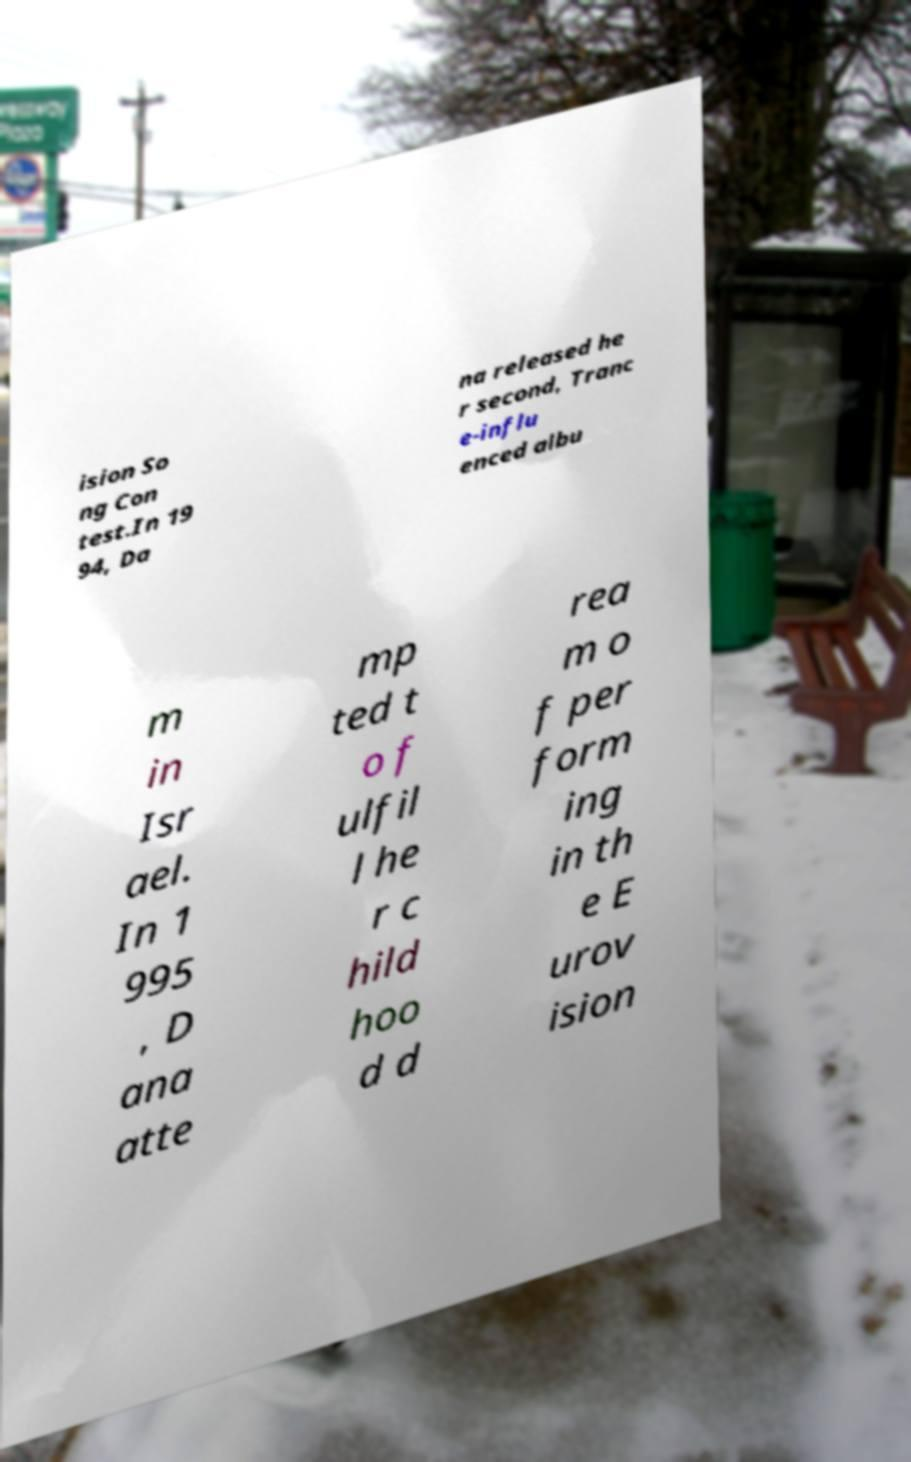I need the written content from this picture converted into text. Can you do that? ision So ng Con test.In 19 94, Da na released he r second, Tranc e-influ enced albu m in Isr ael. In 1 995 , D ana atte mp ted t o f ulfil l he r c hild hoo d d rea m o f per form ing in th e E urov ision 